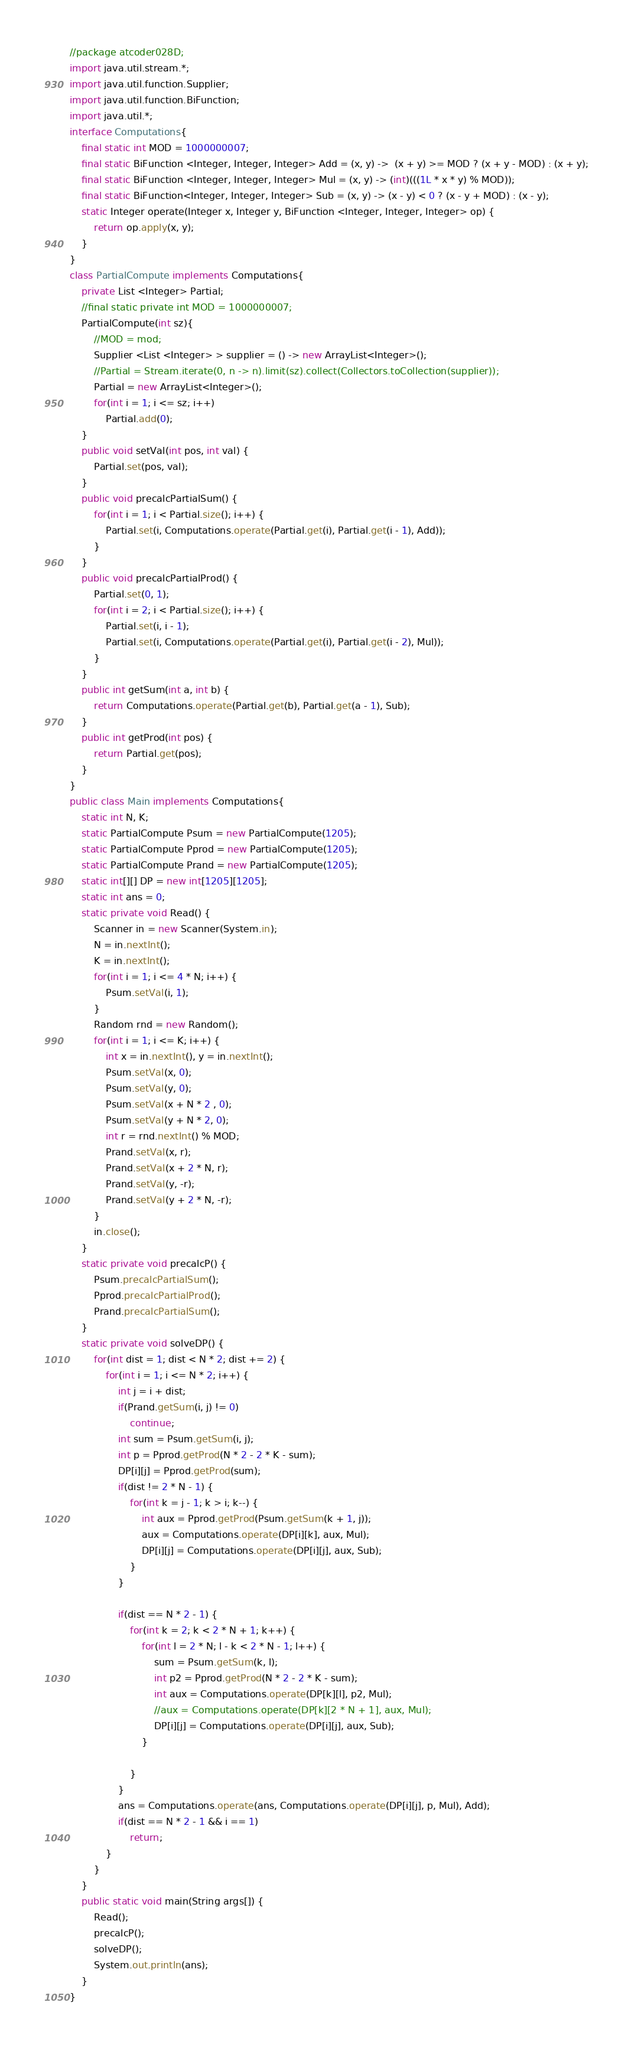<code> <loc_0><loc_0><loc_500><loc_500><_Java_>//package atcoder028D;
import java.util.stream.*;
import java.util.function.Supplier;
import java.util.function.BiFunction;
import java.util.*;
interface Computations{
	final static int MOD = 1000000007;
	final static BiFunction <Integer, Integer, Integer> Add = (x, y) ->  (x + y) >= MOD ? (x + y - MOD) : (x + y);
	final static BiFunction <Integer, Integer, Integer> Mul = (x, y) -> (int)(((1L * x * y) % MOD));
	final static BiFunction<Integer, Integer, Integer> Sub = (x, y) -> (x - y) < 0 ? (x - y + MOD) : (x - y);
	static Integer operate(Integer x, Integer y, BiFunction <Integer, Integer, Integer> op) {
		return op.apply(x, y);
	}
}
class PartialCompute implements Computations{
	private List <Integer> Partial;
	//final static private int MOD = 1000000007; 
	PartialCompute(int sz){
		//MOD = mod;
		Supplier <List <Integer> > supplier = () -> new ArrayList<Integer>();
		//Partial = Stream.iterate(0, n -> n).limit(sz).collect(Collectors.toCollection(supplier));
		Partial = new ArrayList<Integer>();
		for(int i = 1; i <= sz; i++)
			Partial.add(0);
	}
	public void setVal(int pos, int val) {
		Partial.set(pos, val);
	}
	public void precalcPartialSum() {
		for(int i = 1; i < Partial.size(); i++) {
			Partial.set(i, Computations.operate(Partial.get(i), Partial.get(i - 1), Add));
		}
	}
	public void precalcPartialProd() {
		Partial.set(0, 1);
		for(int i = 2; i < Partial.size(); i++) {
			Partial.set(i, i - 1);
			Partial.set(i, Computations.operate(Partial.get(i), Partial.get(i - 2), Mul));
		}
	}
	public int getSum(int a, int b) {
		return Computations.operate(Partial.get(b), Partial.get(a - 1), Sub);
	}
	public int getProd(int pos) {
		return Partial.get(pos);
	}
}
public class Main implements Computations{
	static int N, K;
	static PartialCompute Psum = new PartialCompute(1205);
	static PartialCompute Pprod = new PartialCompute(1205);
	static PartialCompute Prand = new PartialCompute(1205);
	static int[][] DP = new int[1205][1205];
	static int ans = 0;
	static private void Read() {
		Scanner in = new Scanner(System.in);
		N = in.nextInt();
		K = in.nextInt();
		for(int i = 1; i <= 4 * N; i++) {
			Psum.setVal(i, 1);
		}
		Random rnd = new Random();
		for(int i = 1; i <= K; i++) {
			int x = in.nextInt(), y = in.nextInt();
			Psum.setVal(x, 0);
			Psum.setVal(y, 0);
			Psum.setVal(x + N * 2 , 0);
			Psum.setVal(y + N * 2, 0);
			int r = rnd.nextInt() % MOD;
			Prand.setVal(x, r);
			Prand.setVal(x + 2 * N, r);
			Prand.setVal(y, -r);
			Prand.setVal(y + 2 * N, -r);
		}
		in.close();
	}
	static private void precalcP() {
		Psum.precalcPartialSum();
		Pprod.precalcPartialProd();
		Prand.precalcPartialSum();
	}
	static private void solveDP() {
		for(int dist = 1; dist < N * 2; dist += 2) {
			for(int i = 1; i <= N * 2; i++) {
				int j = i + dist;
				if(Prand.getSum(i, j) != 0)
					continue;
				int sum = Psum.getSum(i, j);
				int p = Pprod.getProd(N * 2 - 2 * K - sum);
				DP[i][j] = Pprod.getProd(sum);
				if(dist != 2 * N - 1) {
					for(int k = j - 1; k > i; k--) {
						int aux = Pprod.getProd(Psum.getSum(k + 1, j));
						aux = Computations.operate(DP[i][k], aux, Mul);
						DP[i][j] = Computations.operate(DP[i][j], aux, Sub);
					}
				}
				
				if(dist == N * 2 - 1) {
					for(int k = 2; k < 2 * N + 1; k++) {
						for(int l = 2 * N; l - k < 2 * N - 1; l++) {
							sum = Psum.getSum(k, l);
							int p2 = Pprod.getProd(N * 2 - 2 * K - sum);
							int aux = Computations.operate(DP[k][l], p2, Mul);
							//aux = Computations.operate(DP[k][2 * N + 1], aux, Mul);
							DP[i][j] = Computations.operate(DP[i][j], aux, Sub);
						}
						
					}
				}
				ans = Computations.operate(ans, Computations.operate(DP[i][j], p, Mul), Add);
				if(dist == N * 2 - 1 && i == 1)
					return;
			}
		}
	}
	public static void main(String args[]) {
		Read();
		precalcP();
		solveDP();
		System.out.println(ans);
	}
}
</code> 